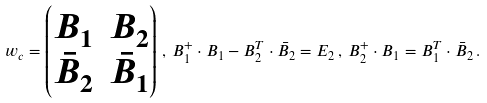Convert formula to latex. <formula><loc_0><loc_0><loc_500><loc_500>w _ { c } = \begin{pmatrix} B _ { 1 } & B _ { 2 } \\ \bar { B } _ { 2 } & \bar { B } _ { 1 } \end{pmatrix} \, , \, B _ { 1 } ^ { + } \cdot B _ { 1 } - B _ { 2 } ^ { T } \cdot \bar { B } _ { 2 } = E _ { 2 } \, , \, B _ { 2 } ^ { + } \cdot B _ { 1 } = B _ { 1 } ^ { T } \cdot \bar { B } _ { 2 } \, .</formula> 